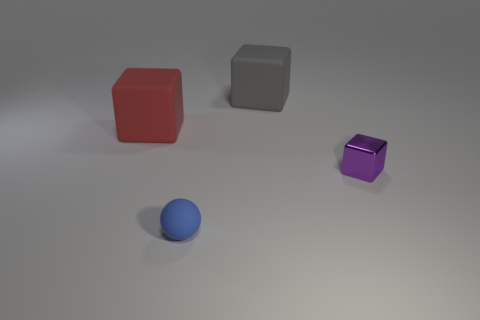What can be inferred about the position of the objects in relation to one another? The positions of the objects form a loose diagonal line across the image, suggesting an intentional placement. The spacing between them indicates no direct interaction; they seem to exist independently within the same space, potentially arranged for comparison or display. 